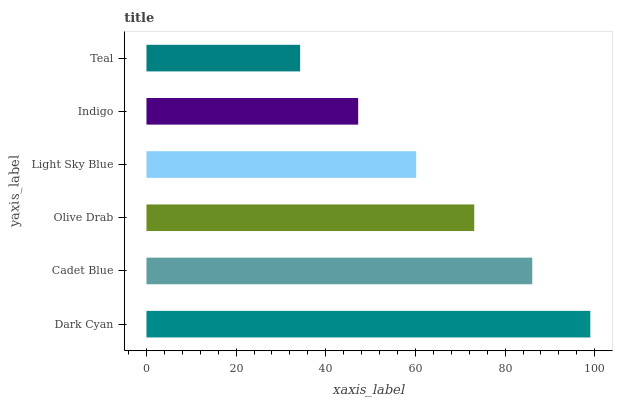Is Teal the minimum?
Answer yes or no. Yes. Is Dark Cyan the maximum?
Answer yes or no. Yes. Is Cadet Blue the minimum?
Answer yes or no. No. Is Cadet Blue the maximum?
Answer yes or no. No. Is Dark Cyan greater than Cadet Blue?
Answer yes or no. Yes. Is Cadet Blue less than Dark Cyan?
Answer yes or no. Yes. Is Cadet Blue greater than Dark Cyan?
Answer yes or no. No. Is Dark Cyan less than Cadet Blue?
Answer yes or no. No. Is Olive Drab the high median?
Answer yes or no. Yes. Is Light Sky Blue the low median?
Answer yes or no. Yes. Is Cadet Blue the high median?
Answer yes or no. No. Is Cadet Blue the low median?
Answer yes or no. No. 